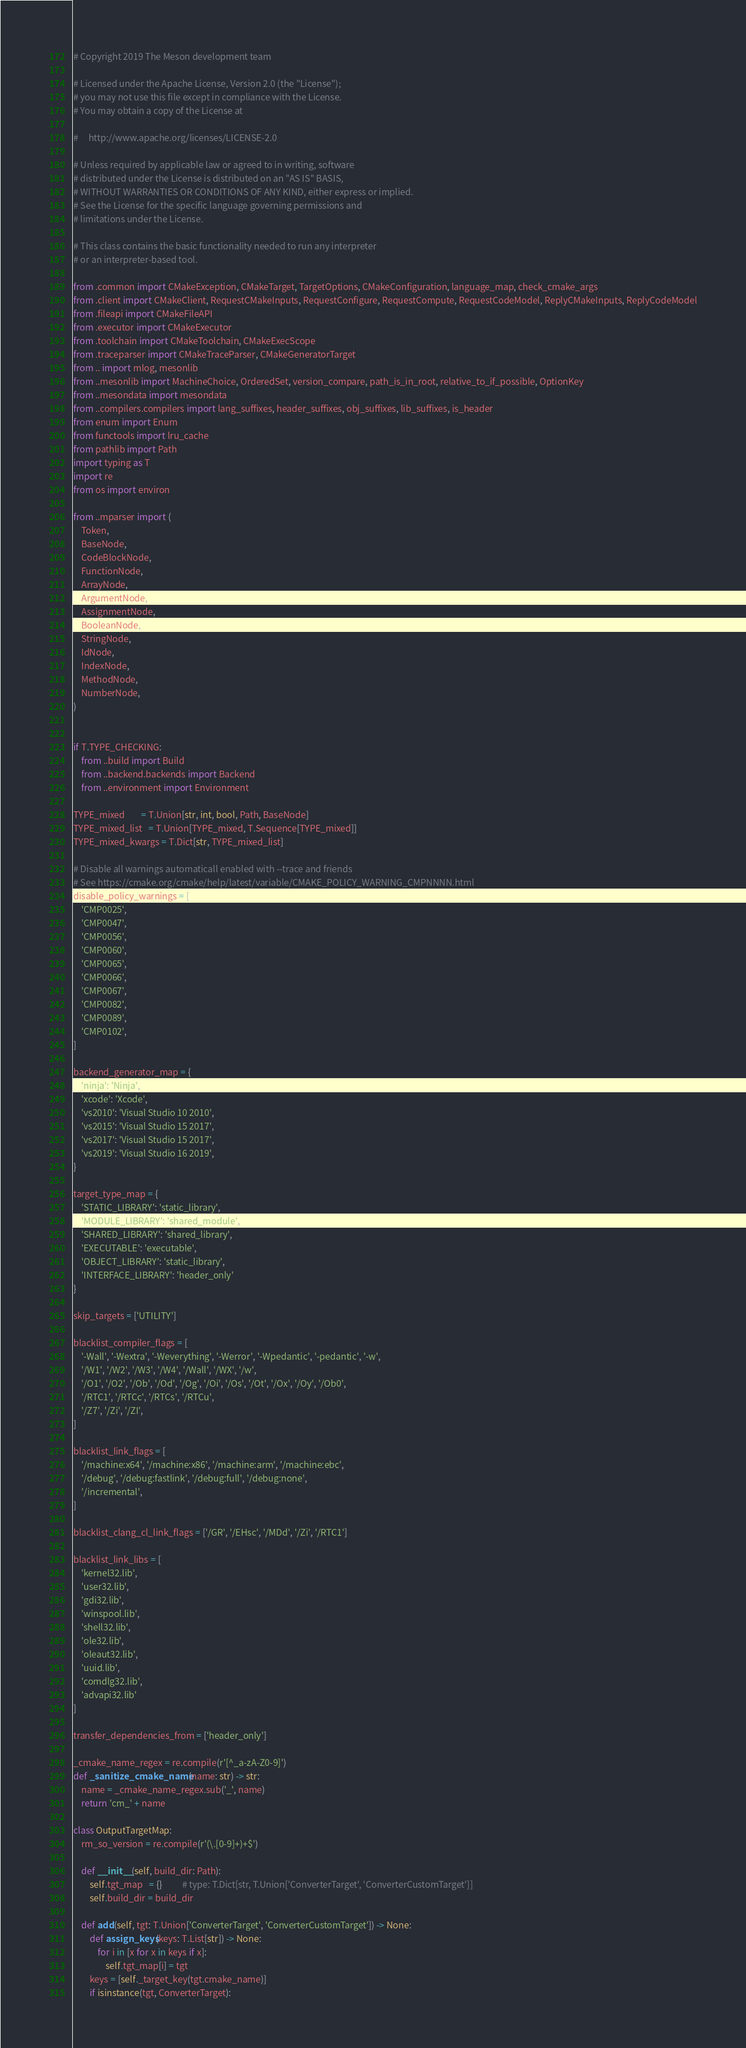Convert code to text. <code><loc_0><loc_0><loc_500><loc_500><_Python_># Copyright 2019 The Meson development team

# Licensed under the Apache License, Version 2.0 (the "License");
# you may not use this file except in compliance with the License.
# You may obtain a copy of the License at

#     http://www.apache.org/licenses/LICENSE-2.0

# Unless required by applicable law or agreed to in writing, software
# distributed under the License is distributed on an "AS IS" BASIS,
# WITHOUT WARRANTIES OR CONDITIONS OF ANY KIND, either express or implied.
# See the License for the specific language governing permissions and
# limitations under the License.

# This class contains the basic functionality needed to run any interpreter
# or an interpreter-based tool.

from .common import CMakeException, CMakeTarget, TargetOptions, CMakeConfiguration, language_map, check_cmake_args
from .client import CMakeClient, RequestCMakeInputs, RequestConfigure, RequestCompute, RequestCodeModel, ReplyCMakeInputs, ReplyCodeModel
from .fileapi import CMakeFileAPI
from .executor import CMakeExecutor
from .toolchain import CMakeToolchain, CMakeExecScope
from .traceparser import CMakeTraceParser, CMakeGeneratorTarget
from .. import mlog, mesonlib
from ..mesonlib import MachineChoice, OrderedSet, version_compare, path_is_in_root, relative_to_if_possible, OptionKey
from ..mesondata import mesondata
from ..compilers.compilers import lang_suffixes, header_suffixes, obj_suffixes, lib_suffixes, is_header
from enum import Enum
from functools import lru_cache
from pathlib import Path
import typing as T
import re
from os import environ

from ..mparser import (
    Token,
    BaseNode,
    CodeBlockNode,
    FunctionNode,
    ArrayNode,
    ArgumentNode,
    AssignmentNode,
    BooleanNode,
    StringNode,
    IdNode,
    IndexNode,
    MethodNode,
    NumberNode,
)


if T.TYPE_CHECKING:
    from ..build import Build
    from ..backend.backends import Backend
    from ..environment import Environment

TYPE_mixed        = T.Union[str, int, bool, Path, BaseNode]
TYPE_mixed_list   = T.Union[TYPE_mixed, T.Sequence[TYPE_mixed]]
TYPE_mixed_kwargs = T.Dict[str, TYPE_mixed_list]

# Disable all warnings automaticall enabled with --trace and friends
# See https://cmake.org/cmake/help/latest/variable/CMAKE_POLICY_WARNING_CMPNNNN.html
disable_policy_warnings = [
    'CMP0025',
    'CMP0047',
    'CMP0056',
    'CMP0060',
    'CMP0065',
    'CMP0066',
    'CMP0067',
    'CMP0082',
    'CMP0089',
    'CMP0102',
]

backend_generator_map = {
    'ninja': 'Ninja',
    'xcode': 'Xcode',
    'vs2010': 'Visual Studio 10 2010',
    'vs2015': 'Visual Studio 15 2017',
    'vs2017': 'Visual Studio 15 2017',
    'vs2019': 'Visual Studio 16 2019',
}

target_type_map = {
    'STATIC_LIBRARY': 'static_library',
    'MODULE_LIBRARY': 'shared_module',
    'SHARED_LIBRARY': 'shared_library',
    'EXECUTABLE': 'executable',
    'OBJECT_LIBRARY': 'static_library',
    'INTERFACE_LIBRARY': 'header_only'
}

skip_targets = ['UTILITY']

blacklist_compiler_flags = [
    '-Wall', '-Wextra', '-Weverything', '-Werror', '-Wpedantic', '-pedantic', '-w',
    '/W1', '/W2', '/W3', '/W4', '/Wall', '/WX', '/w',
    '/O1', '/O2', '/Ob', '/Od', '/Og', '/Oi', '/Os', '/Ot', '/Ox', '/Oy', '/Ob0',
    '/RTC1', '/RTCc', '/RTCs', '/RTCu',
    '/Z7', '/Zi', '/ZI',
]

blacklist_link_flags = [
    '/machine:x64', '/machine:x86', '/machine:arm', '/machine:ebc',
    '/debug', '/debug:fastlink', '/debug:full', '/debug:none',
    '/incremental',
]

blacklist_clang_cl_link_flags = ['/GR', '/EHsc', '/MDd', '/Zi', '/RTC1']

blacklist_link_libs = [
    'kernel32.lib',
    'user32.lib',
    'gdi32.lib',
    'winspool.lib',
    'shell32.lib',
    'ole32.lib',
    'oleaut32.lib',
    'uuid.lib',
    'comdlg32.lib',
    'advapi32.lib'
]

transfer_dependencies_from = ['header_only']

_cmake_name_regex = re.compile(r'[^_a-zA-Z0-9]')
def _sanitize_cmake_name(name: str) -> str:
    name = _cmake_name_regex.sub('_', name)
    return 'cm_' + name

class OutputTargetMap:
    rm_so_version = re.compile(r'(\.[0-9]+)+$')

    def __init__(self, build_dir: Path):
        self.tgt_map   = {}          # type: T.Dict[str, T.Union['ConverterTarget', 'ConverterCustomTarget']]
        self.build_dir = build_dir

    def add(self, tgt: T.Union['ConverterTarget', 'ConverterCustomTarget']) -> None:
        def assign_keys(keys: T.List[str]) -> None:
            for i in [x for x in keys if x]:
                self.tgt_map[i] = tgt
        keys = [self._target_key(tgt.cmake_name)]
        if isinstance(tgt, ConverterTarget):</code> 